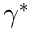Convert formula to latex. <formula><loc_0><loc_0><loc_500><loc_500>\gamma ^ { * }</formula> 